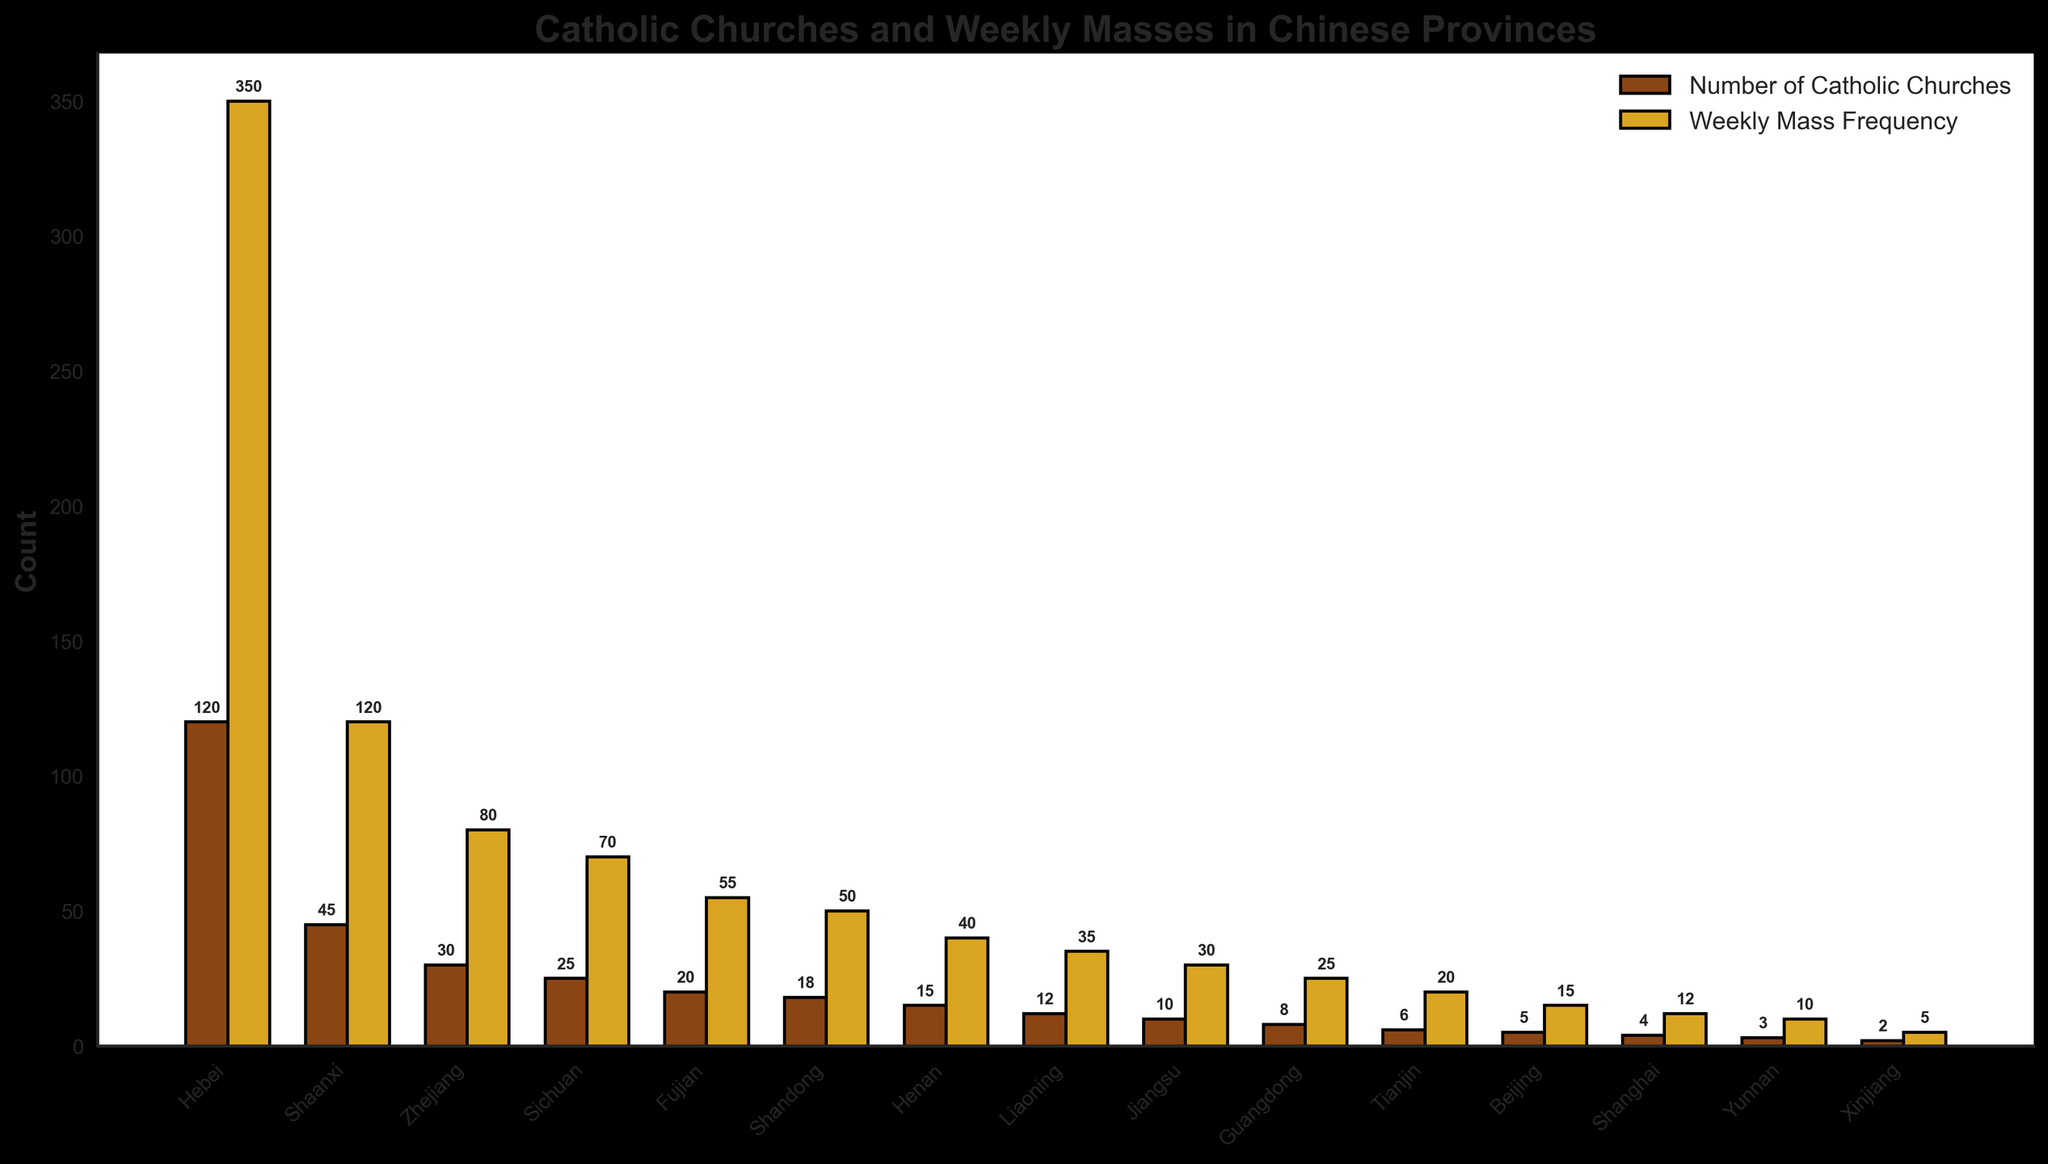What is the province with the highest number of Catholic churches? The bar representing Hebei is the tallest among the bars indicating the number of Catholic churches.
Answer: Hebei Which province has the lowest weekly mass frequency? The smallest bar in the weekly mass frequency category corresponds to Xinjiang.
Answer: Xinjiang What is the difference in the number of Catholic churches between Henan and Liaoning? Henan has 15 Catholic churches and Liaoning has 12. The difference is 15 - 12 = 3.
Answer: 3 Among Zhejiang, Sichuan, and Fujian, which province has the highest weekly mass frequency? The bar representing Zhejiang is the tallest among these three provinces for the weekly mass frequency.
Answer: Zhejiang How many provinces have more than 10 Catholic churches? The bars representing Hebei, Shaanxi, Zhejiang, Sichuan, Fujian, Shandong, Henan, and Liaoning all exceed 10. This totals to 8 provinces.
Answer: 8 Compare the weekly mass frequency between Beijing and Shanghai. Which has more and by how much? Beijing has a weekly mass frequency of 15 while Shanghai has 12. The difference is 15 - 12 = 3. Hence, Beijing has 3 more weekly masses than Shanghai.
Answer: Beijing, 3 What is the total number of Catholic churches in Jiangsu, Guangdong, and Tianjin combined? Jiangsu has 10, Guangdong has 8, and Tianjin has 6. The total is 10 + 8 + 6 = 24.
Answer: 24 Compare the number of Catholic churches and weekly mass frequency in Shandong. In Shandong, the bars for the number of Catholic churches and weekly mass frequency represent 18 and 50, respectively.
Answer: Churches: 18, Weekly Masses: 50 Which province has a ratio close to 1 Catholic church per 10 weekly masses? Shandong has 18 churches and 50 weekly masses. The ratio is 18/50 = 0.36, which rounds to say Jiangsu, as it has 10 churches and 30 weekly masses, keeping the ratio close to 3 which rounds to approximately 1 church per 10 masses.
Answer: Jiangsu 